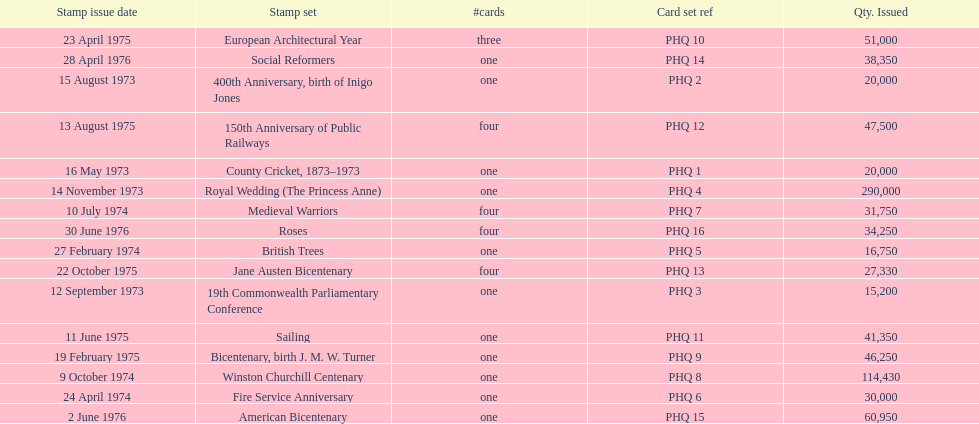Which stamp sets contained more than one card? Medieval Warriors, European Architectural Year, 150th Anniversary of Public Railways, Jane Austen Bicentenary, Roses. Of those stamp sets, which contains a unique number of cards? European Architectural Year. 